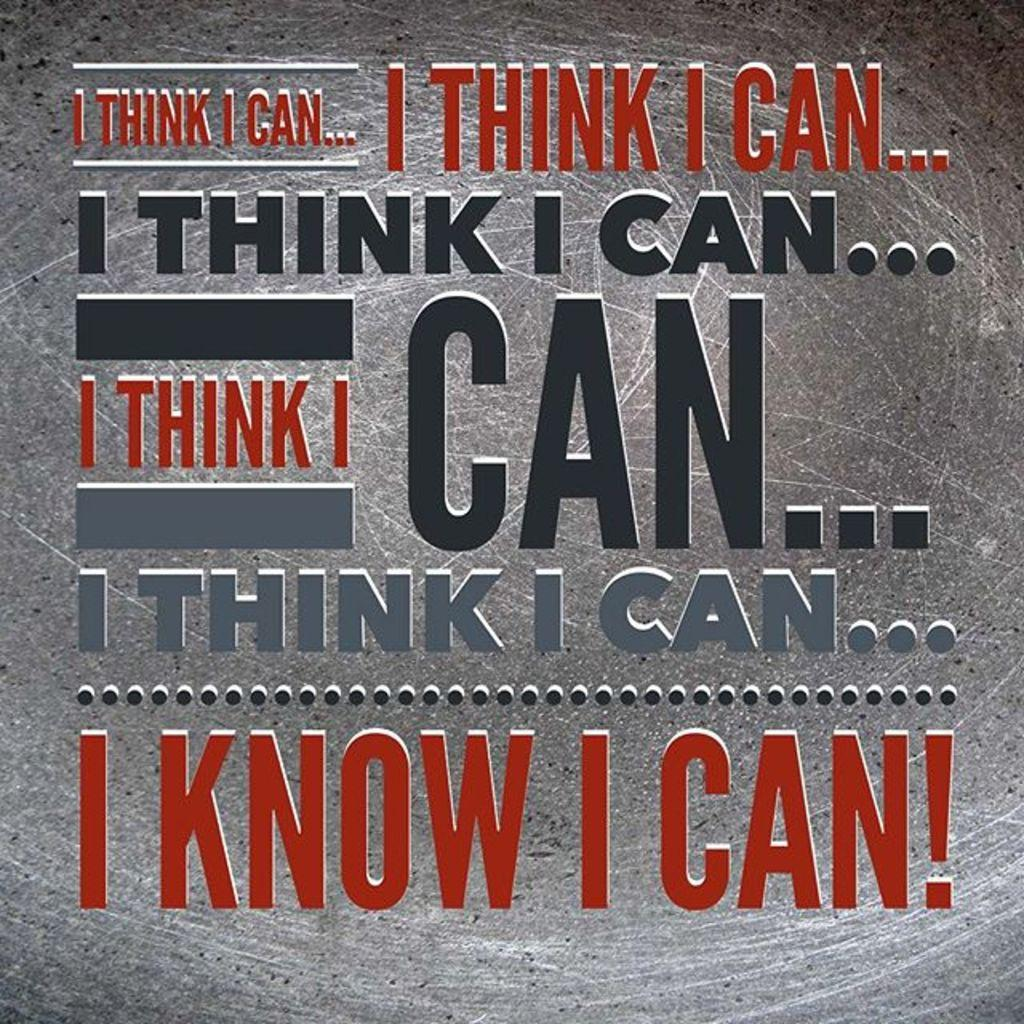<image>
Offer a succinct explanation of the picture presented. A motivational sign that says I think I can five times then finished with I know I can! 